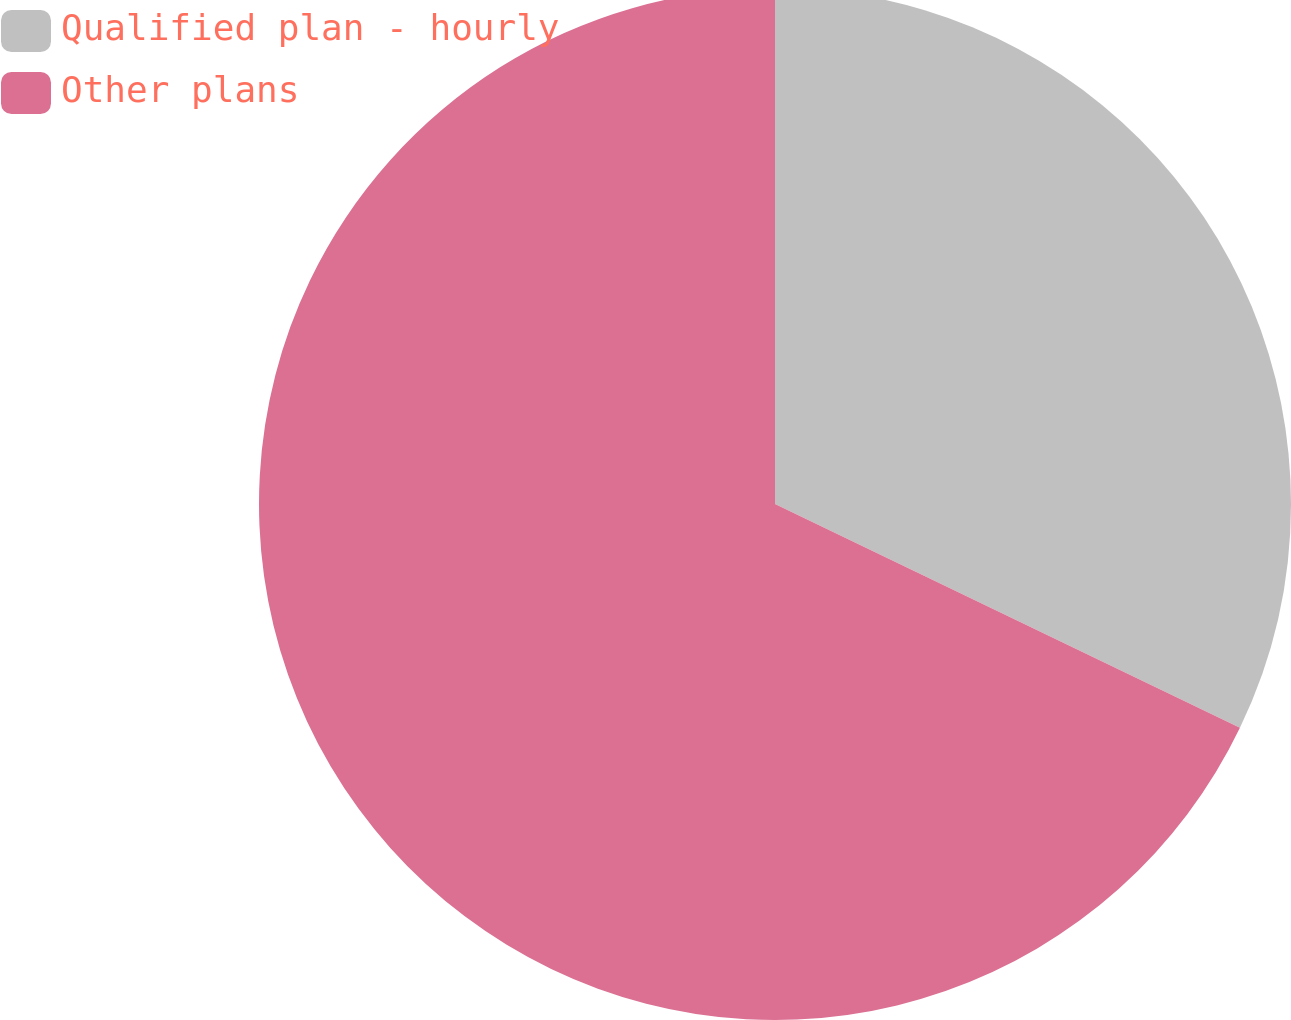Convert chart to OTSL. <chart><loc_0><loc_0><loc_500><loc_500><pie_chart><fcel>Qualified plan - hourly<fcel>Other plans<nl><fcel>32.14%<fcel>67.86%<nl></chart> 